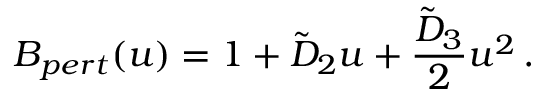Convert formula to latex. <formula><loc_0><loc_0><loc_500><loc_500>B _ { p e r t } ( u ) = 1 + \tilde { D } _ { 2 } u + { \frac { \tilde { D } _ { 3 } } { 2 } } u ^ { 2 } \, .</formula> 